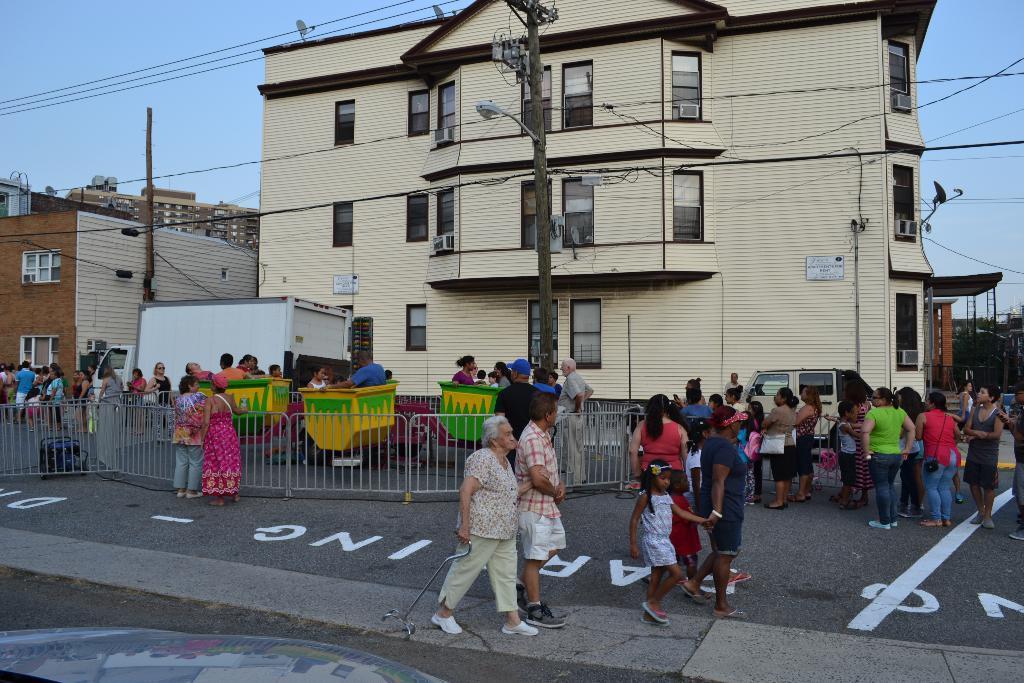How would you summarize this image in a sentence or two? In this image, we can see persons wearing clothes. There is a street pole and vehicle in front of the building. There is a barricade and fun ride in the middle of the image. There is an another building on the left side of the image. There is a sky at the top of the image. 